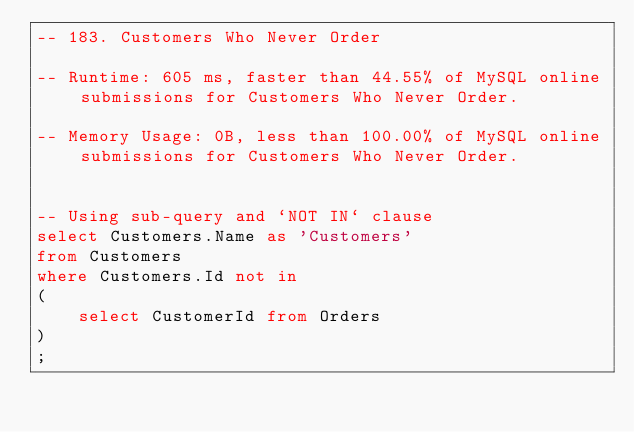<code> <loc_0><loc_0><loc_500><loc_500><_SQL_>-- 183. Customers Who Never Order

-- Runtime: 605 ms, faster than 44.55% of MySQL online submissions for Customers Who Never Order.

-- Memory Usage: 0B, less than 100.00% of MySQL online submissions for Customers Who Never Order.


-- Using sub-query and `NOT IN` clause
select Customers.Name as 'Customers'
from Customers
where Customers.Id not in
(
    select CustomerId from Orders
)
;</code> 